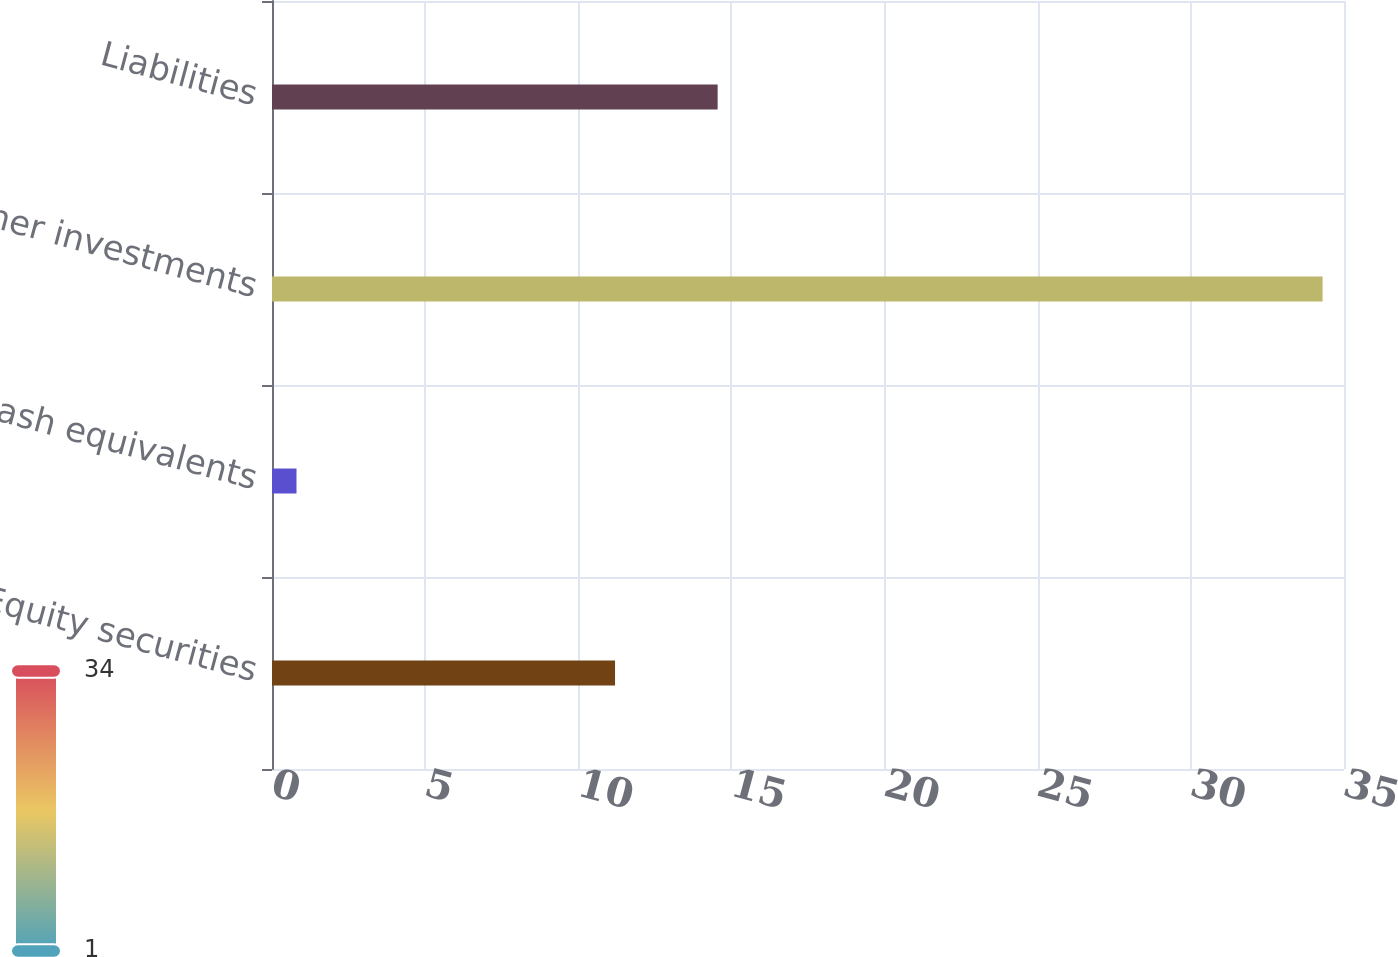<chart> <loc_0><loc_0><loc_500><loc_500><bar_chart><fcel>Equity securities<fcel>Cash equivalents<fcel>Other investments<fcel>Liabilities<nl><fcel>11.2<fcel>0.8<fcel>34.3<fcel>14.55<nl></chart> 